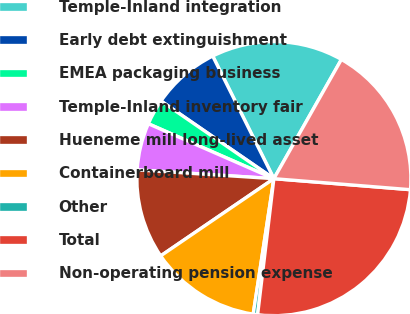Convert chart to OTSL. <chart><loc_0><loc_0><loc_500><loc_500><pie_chart><fcel>Temple-Inland integration<fcel>Early debt extinguishment<fcel>EMEA packaging business<fcel>Temple-Inland inventory fair<fcel>Hueneme mill long-lived asset<fcel>Containerboard mill<fcel>Other<fcel>Total<fcel>Non-operating pension expense<nl><fcel>15.57%<fcel>8.04%<fcel>3.03%<fcel>5.54%<fcel>10.55%<fcel>13.06%<fcel>0.52%<fcel>25.61%<fcel>18.08%<nl></chart> 